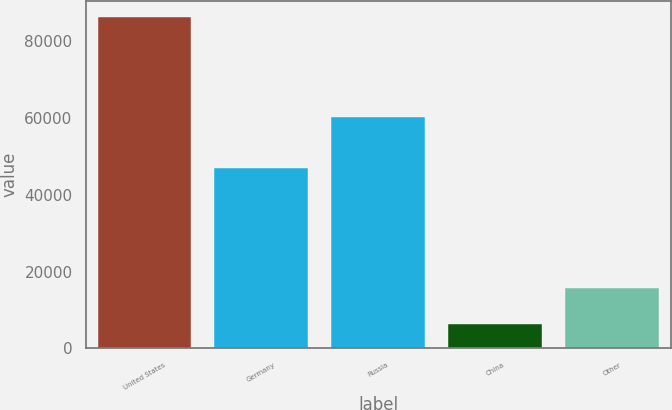<chart> <loc_0><loc_0><loc_500><loc_500><bar_chart><fcel>United States<fcel>Germany<fcel>Russia<fcel>China<fcel>Other<nl><fcel>86226<fcel>47019<fcel>60151<fcel>6424<fcel>15674<nl></chart> 